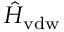Convert formula to latex. <formula><loc_0><loc_0><loc_500><loc_500>\hat { H } _ { v d w }</formula> 